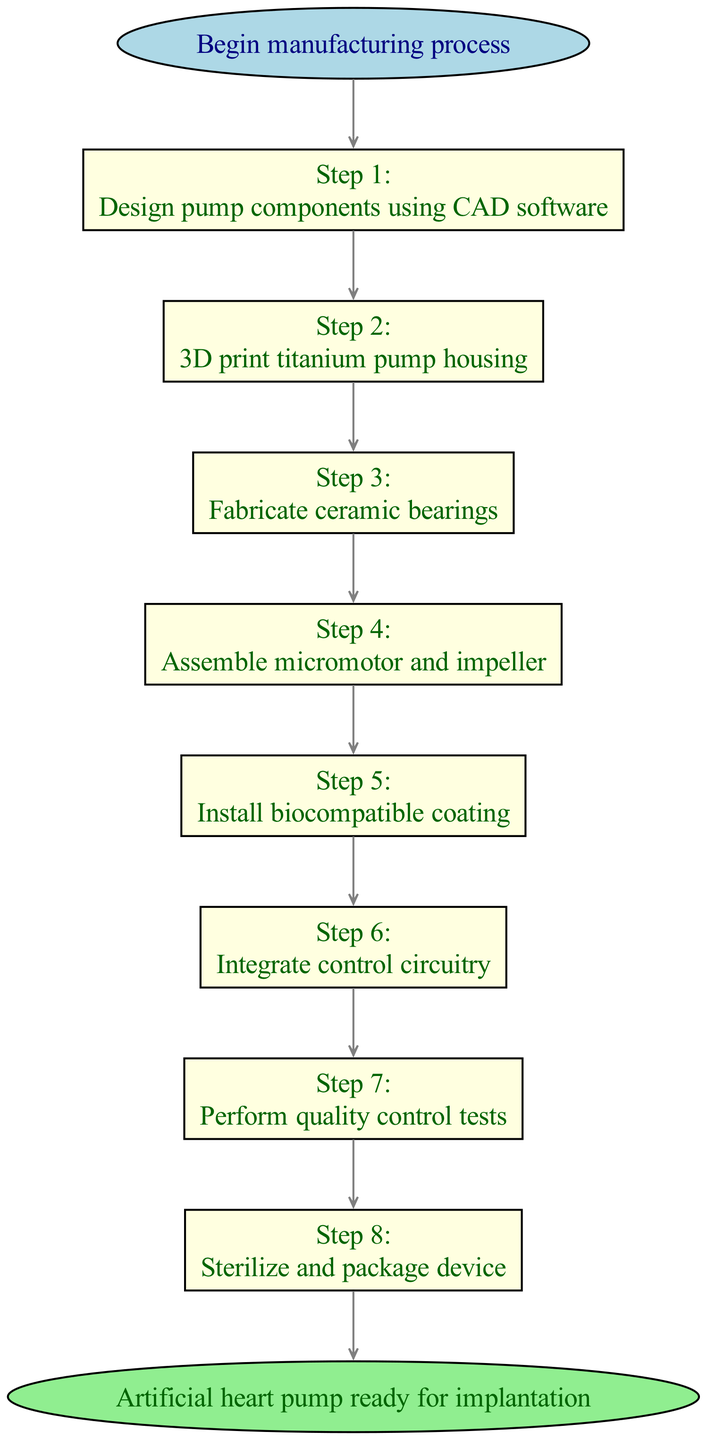What is the first step in the manufacturing process? The first step in the diagram is labeled "Design pump components using CAD software", which is shown as the output from the start node leading to step 1.
Answer: Design pump components using CAD software How many steps are there in total in the manufacturing process? The diagram presents eight process steps, each clearly numbered from step 1 to step 8, therefore the total count of steps is derived from the numbering system used.
Answer: 8 What material is used for the pump housing? Referring to step 2, the diagram states "3D print titanium pump housing", which identifies the material used for this specific component.
Answer: Titanium What is the last step before the device is ready for implantation? According to the diagram, the last step in the process is "Sterilize and package device", which is step 8, immediately preceding the end node.
Answer: Sterilize and package device What is the relation between step 3 and step 4? The diagram indicates a direct flow from step 3 "Fabricate ceramic bearings" to step 4 "Assemble micromotor and impeller", demonstrating the sequential relationship between these two steps.
Answer: Sequential flow What step comes before the installation of the biocompatible coating? By analyzing the diagram, step 4 which is "Assemble micromotor and impeller" directly precedes step 5, where the biocompatible coating is installed.
Answer: Assemble micromotor and impeller Which step involves integrating the control circuitry? Step 6 in the diagram is specified as "Integrate control circuitry", and it clearly identifies this specific process within the manufacturing sequence.
Answer: Integrate control circuitry What type of tests are performed in step 7? The diagram states "Perform quality control tests" in step 7, which categorically describes the type of tests conducted at this stage of manufacturing.
Answer: Quality control tests What initializes the manufacturing process? The diagram shows that the manufacturing process starts with the node labeled "Begin manufacturing process", indicating the starting point of the workflow.
Answer: Begin manufacturing process 